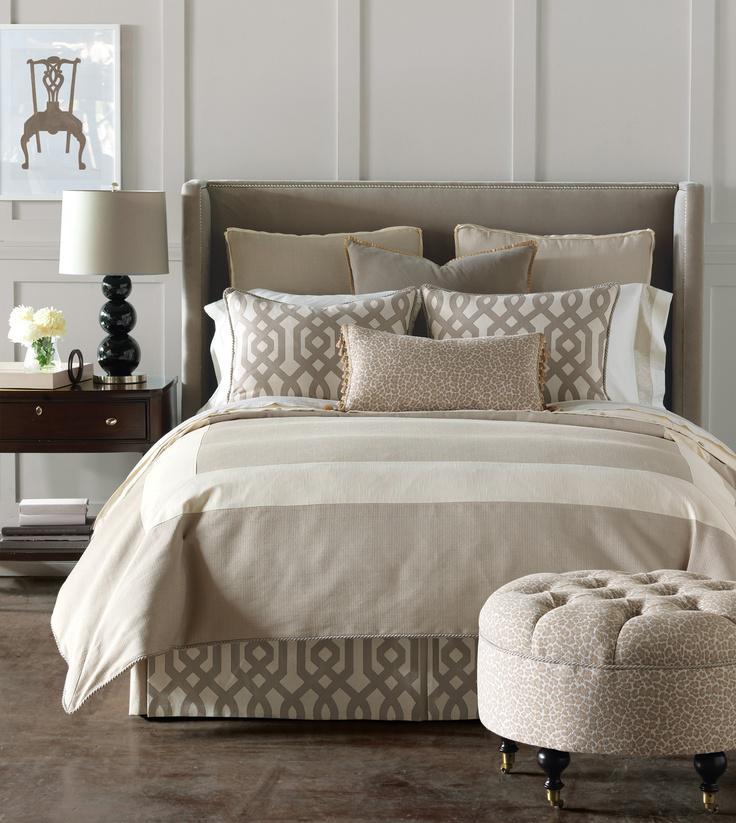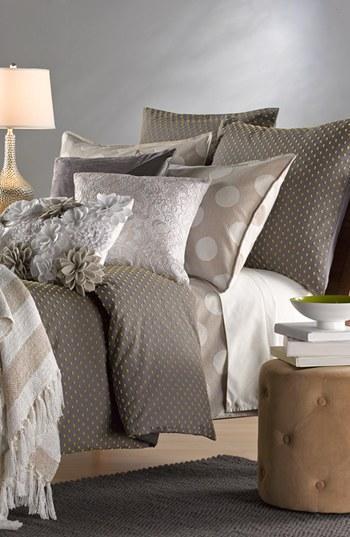The first image is the image on the left, the second image is the image on the right. Evaluate the accuracy of this statement regarding the images: "Each image features a bed made up with different pillows.". Is it true? Answer yes or no. Yes. The first image is the image on the left, the second image is the image on the right. Analyze the images presented: Is the assertion "A window is letting in natural light." valid? Answer yes or no. No. 